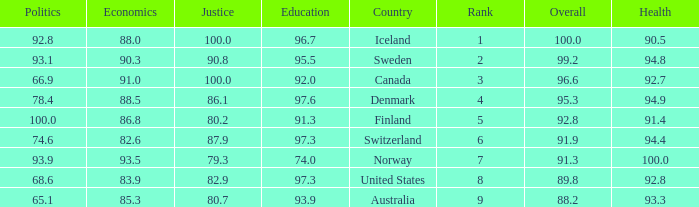What's the health score with justice being 80.7 93.3. 